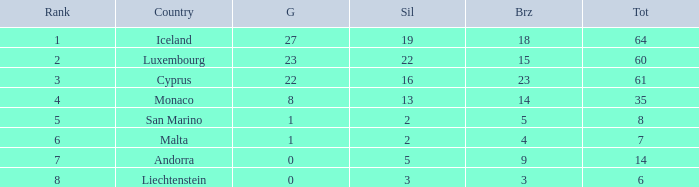Where does Iceland rank with under 19 silvers? None. 